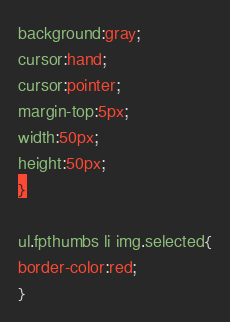Convert code to text. <code><loc_0><loc_0><loc_500><loc_500><_CSS_>background:gray;
cursor:hand;
cursor:pointer;
margin-top:5px;
width:50px;
height:50px;
}

ul.fpthumbs li img.selected{
border-color:red;
}
</code> 